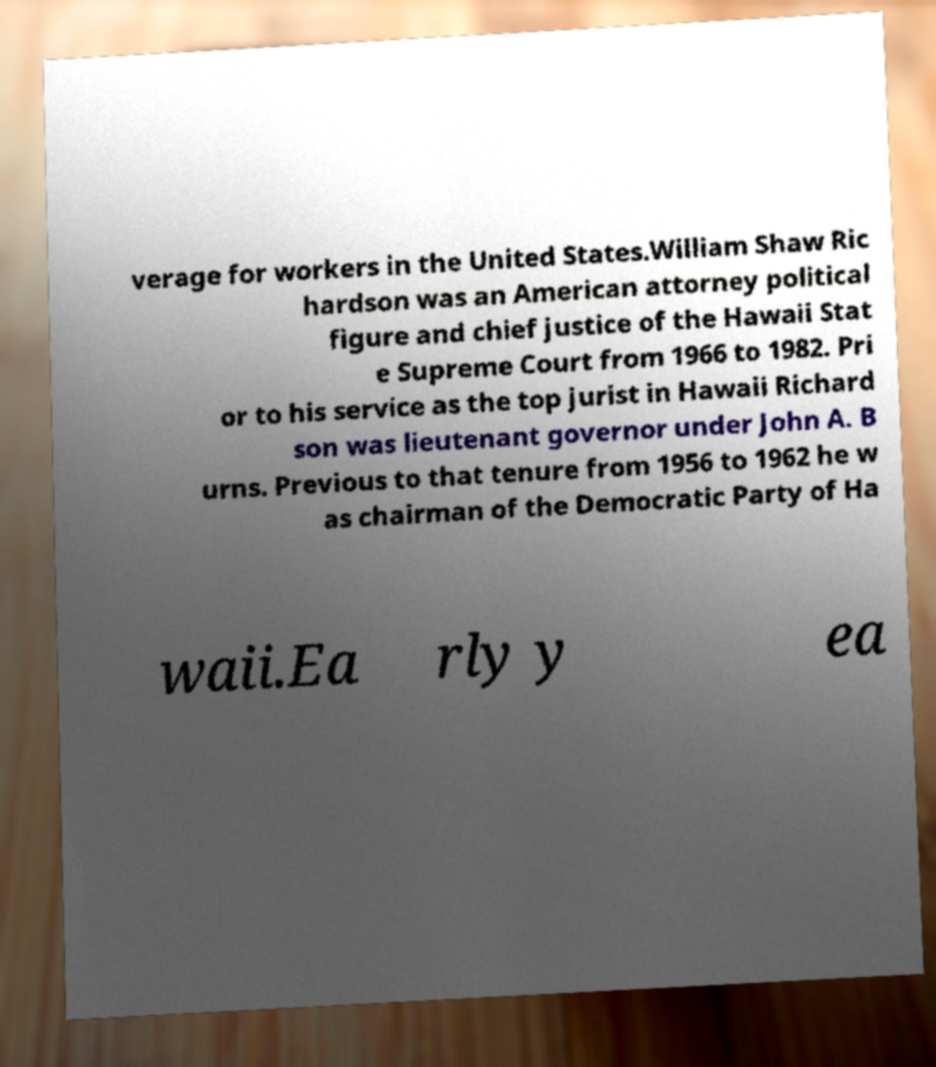Please identify and transcribe the text found in this image. verage for workers in the United States.William Shaw Ric hardson was an American attorney political figure and chief justice of the Hawaii Stat e Supreme Court from 1966 to 1982. Pri or to his service as the top jurist in Hawaii Richard son was lieutenant governor under John A. B urns. Previous to that tenure from 1956 to 1962 he w as chairman of the Democratic Party of Ha waii.Ea rly y ea 